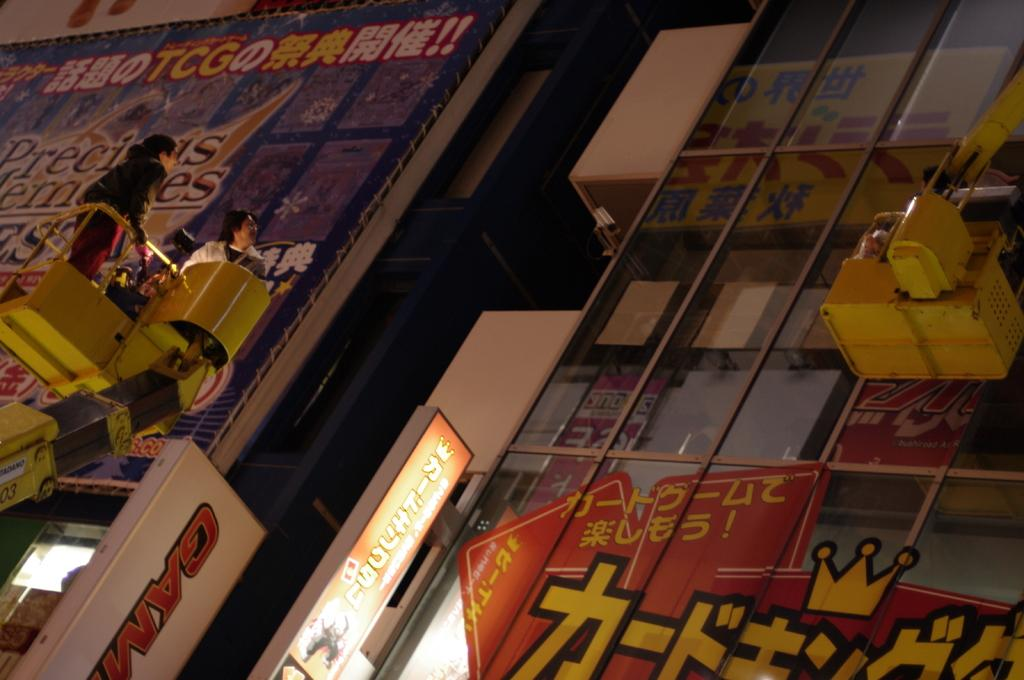<image>
Describe the image concisely. a person in a GAM cherry picker cleaning billboard covered windows 